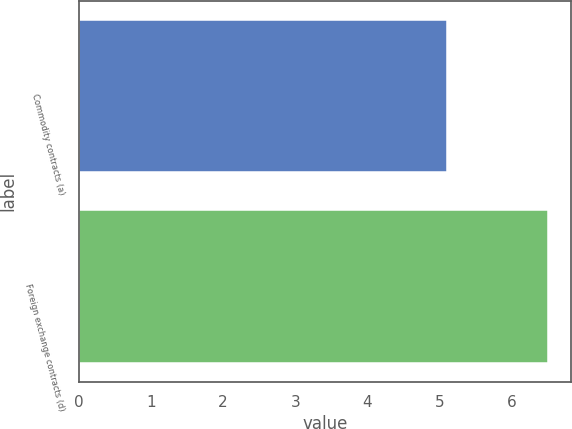Convert chart to OTSL. <chart><loc_0><loc_0><loc_500><loc_500><bar_chart><fcel>Commodity contracts (a)<fcel>Foreign exchange contracts (d)<nl><fcel>5.1<fcel>6.5<nl></chart> 